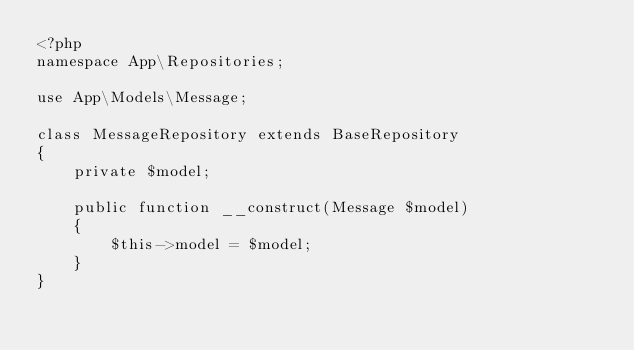<code> <loc_0><loc_0><loc_500><loc_500><_PHP_><?php
namespace App\Repositories;

use App\Models\Message;

class MessageRepository extends BaseRepository
{
    private $model;

    public function __construct(Message $model)
    {
        $this->model = $model;
    }
}</code> 